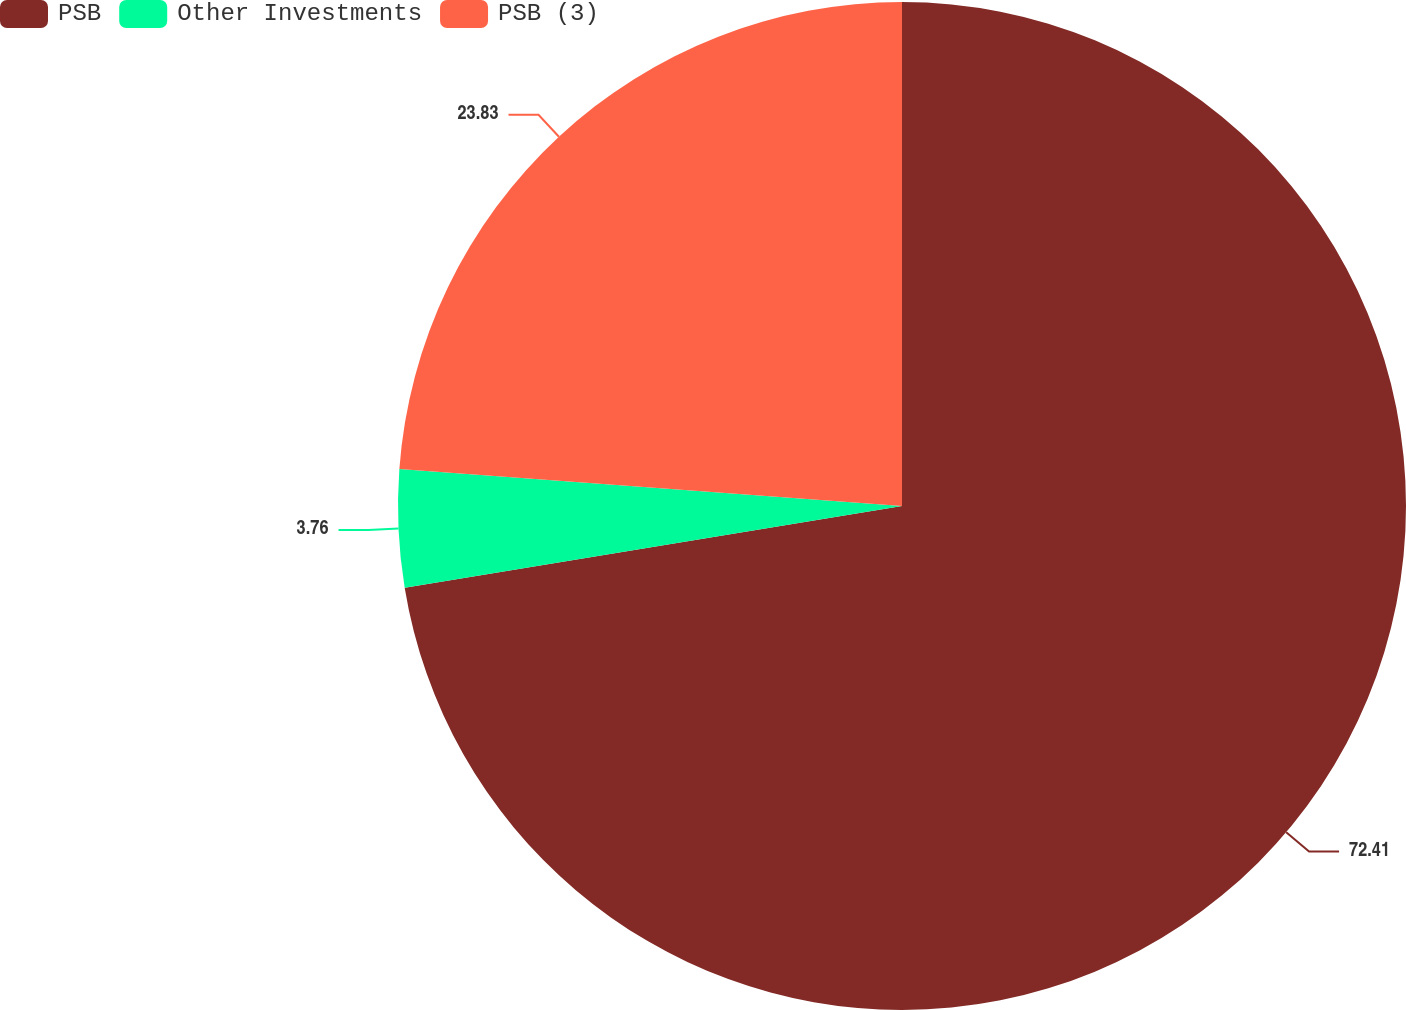<chart> <loc_0><loc_0><loc_500><loc_500><pie_chart><fcel>PSB<fcel>Other Investments<fcel>PSB (3)<nl><fcel>72.4%<fcel>3.76%<fcel>23.83%<nl></chart> 